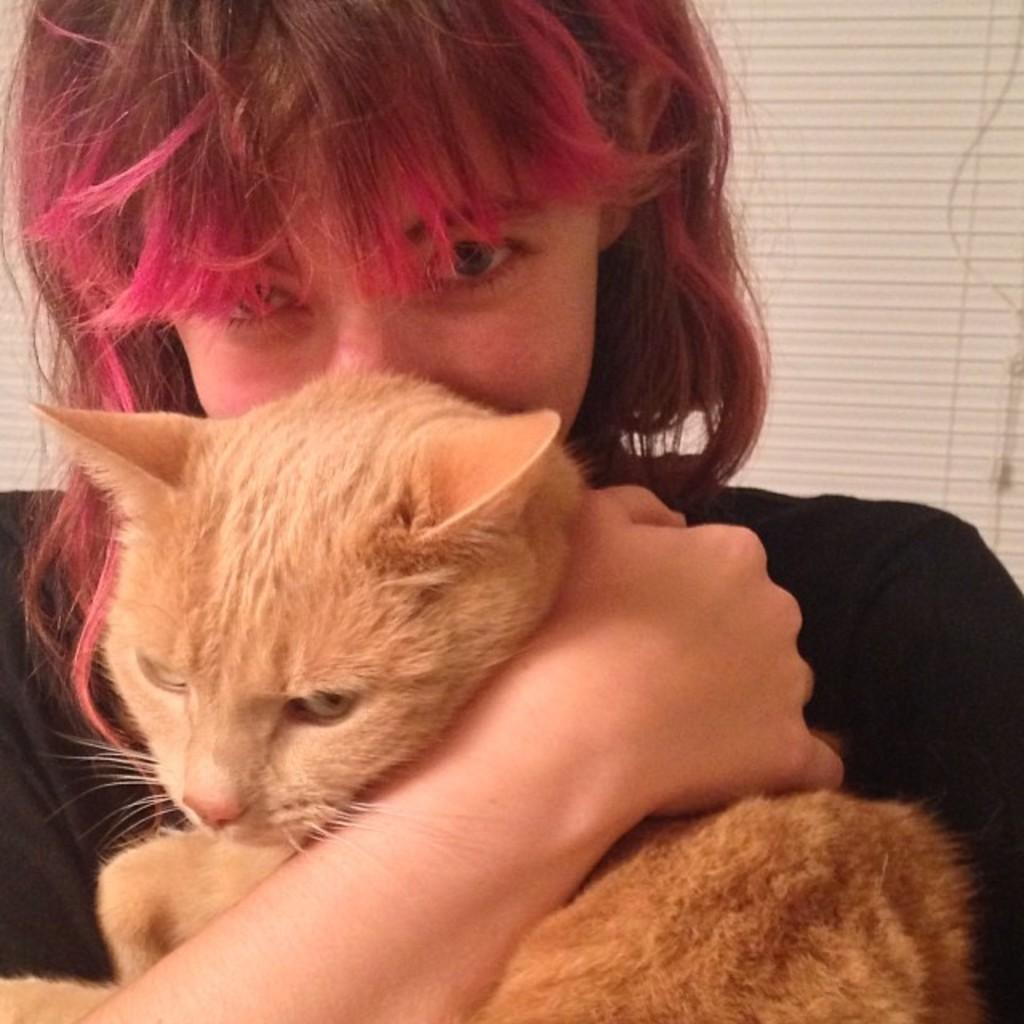Who is the main subject in the picture? There is a woman in the picture. What is the woman wearing? The woman is wearing a black dress. What is the woman holding in her hand? The woman is holding a brown cat in her hand. What type of organization does the tooth belong to in the image? There is no tooth present in the image, so it cannot be associated with any organization. 